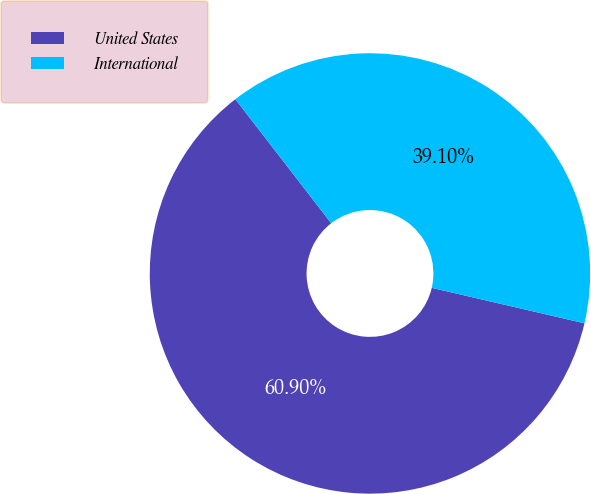Convert chart. <chart><loc_0><loc_0><loc_500><loc_500><pie_chart><fcel>United States<fcel>International<nl><fcel>60.9%<fcel>39.1%<nl></chart> 